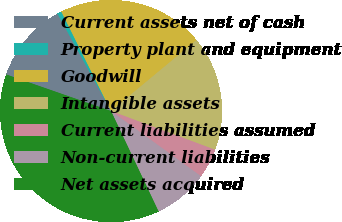Convert chart to OTSL. <chart><loc_0><loc_0><loc_500><loc_500><pie_chart><fcel>Current assets net of cash<fcel>Property plant and equipment<fcel>Goodwill<fcel>Intangible assets<fcel>Current liabilities assumed<fcel>Non-current liabilities<fcel>Net assets acquired<nl><fcel>11.66%<fcel>0.63%<fcel>21.35%<fcel>16.7%<fcel>4.31%<fcel>7.98%<fcel>37.38%<nl></chart> 